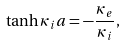Convert formula to latex. <formula><loc_0><loc_0><loc_500><loc_500>\tanh \kappa _ { i } a = - \frac { \kappa _ { e } } { \kappa _ { i } } ,</formula> 